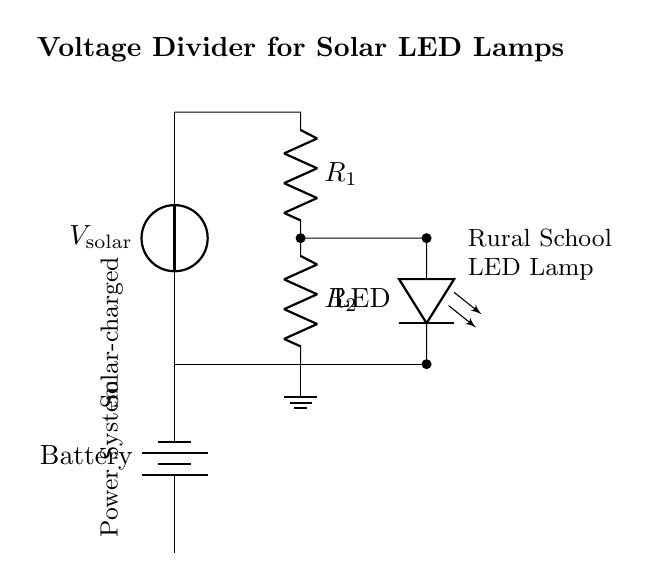what is the purpose of the voltage divider in this circuit? The voltage divider is used to reduce the voltage from the solar panel to a suitable level for the LED lamp. It allows for efficient usage of the solar power to ensure the LED operates safely without damage.
Answer: reduce voltage what type of components are R1 and R2? R1 and R2 are resistors, which are used in the voltage divider to create different voltage levels by dividing the supply voltage based on their resistances.
Answer: resistors how many volts does the solar panel provide? The diagram indicates a voltage source labeled as V solar; if not specified here, it typically can be considered as 5V based on common panel specifications for similar systems.
Answer: 5 volts what is the output voltage across the LED? The output voltage across the LED is determined by the values of R1 and R2 in relation to the input voltage. A voltage divider formula can be used to find this; without specific resistor values, we can assume it's designed to optimize LED performance, often around 3 volts in such applications.
Answer: 3 volts how does the LED indicate the proper function of the circuit? The LED, when connected in series with the output of the voltage divider, illuminates to show that the circuit is functioning correctly and that voltage is being supplied appropriately from the solar panel through the divider. If the LED is not lit, it often indicates a problem in the circuit.
Answer: illuminates what is the significance of the battery in this circuit? The battery storage element in the circuit provides a reservoir of power that can be used when sunlight is not available, ensuring that the LED can continue to function during periods of low solar input.
Answer: energy storage 